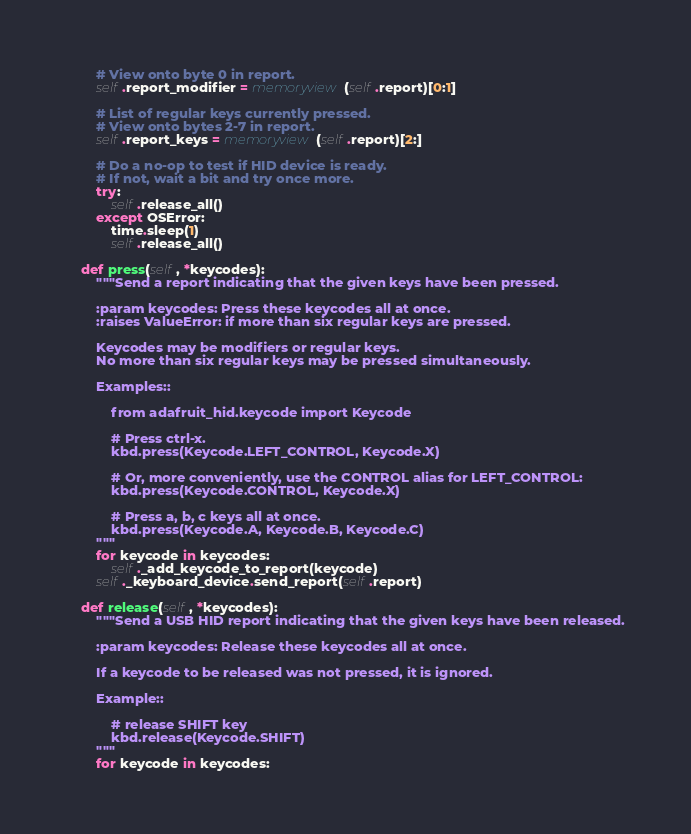Convert code to text. <code><loc_0><loc_0><loc_500><loc_500><_Python_>        # View onto byte 0 in report.
        self.report_modifier = memoryview(self.report)[0:1]

        # List of regular keys currently pressed.
        # View onto bytes 2-7 in report.
        self.report_keys = memoryview(self.report)[2:]

        # Do a no-op to test if HID device is ready.
        # If not, wait a bit and try once more.
        try:
            self.release_all()
        except OSError:
            time.sleep(1)
            self.release_all()

    def press(self, *keycodes):
        """Send a report indicating that the given keys have been pressed.

        :param keycodes: Press these keycodes all at once.
        :raises ValueError: if more than six regular keys are pressed.

        Keycodes may be modifiers or regular keys.
        No more than six regular keys may be pressed simultaneously.

        Examples::

            from adafruit_hid.keycode import Keycode

            # Press ctrl-x.
            kbd.press(Keycode.LEFT_CONTROL, Keycode.X)

            # Or, more conveniently, use the CONTROL alias for LEFT_CONTROL:
            kbd.press(Keycode.CONTROL, Keycode.X)

            # Press a, b, c keys all at once.
            kbd.press(Keycode.A, Keycode.B, Keycode.C)
        """
        for keycode in keycodes:
            self._add_keycode_to_report(keycode)
        self._keyboard_device.send_report(self.report)

    def release(self, *keycodes):
        """Send a USB HID report indicating that the given keys have been released.

        :param keycodes: Release these keycodes all at once.

        If a keycode to be released was not pressed, it is ignored.

        Example::

            # release SHIFT key
            kbd.release(Keycode.SHIFT)
        """
        for keycode in keycodes:</code> 